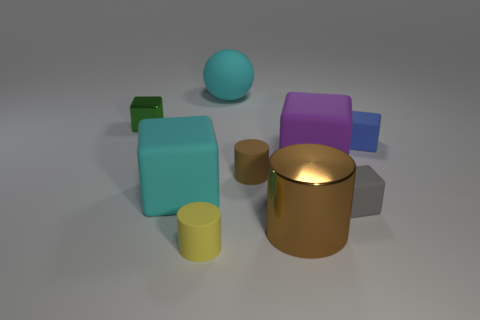Subtract all small green metallic blocks. How many blocks are left? 4 Subtract all blue balls. How many brown cylinders are left? 2 Subtract 2 cubes. How many cubes are left? 3 Subtract all yellow cylinders. How many cylinders are left? 2 Add 1 tiny purple rubber blocks. How many objects exist? 10 Subtract all blocks. How many objects are left? 4 Add 3 cubes. How many cubes exist? 8 Subtract 0 cyan cylinders. How many objects are left? 9 Subtract all blue cylinders. Subtract all brown spheres. How many cylinders are left? 3 Subtract all large gray rubber cubes. Subtract all cyan objects. How many objects are left? 7 